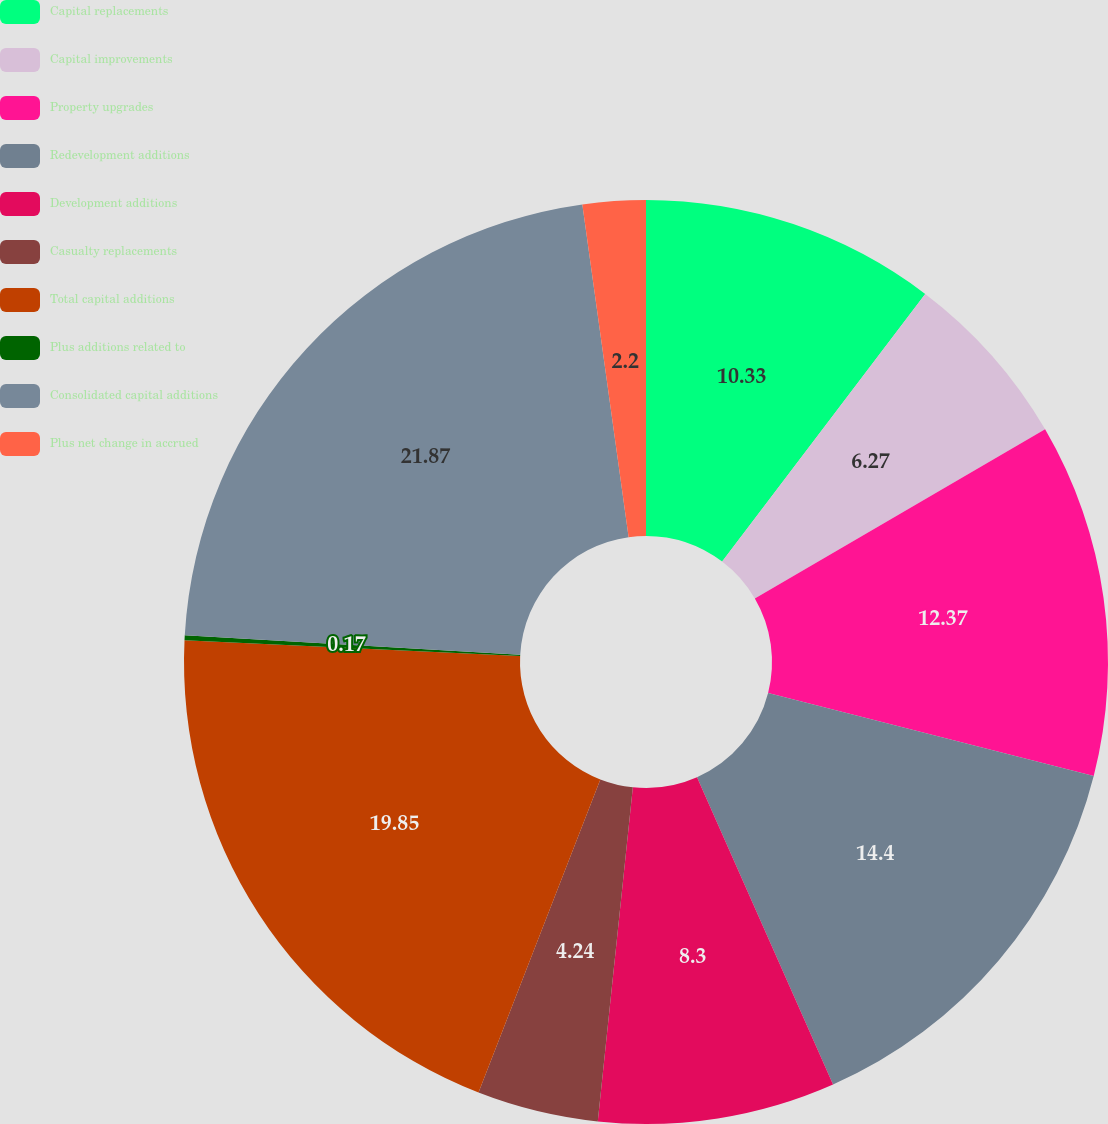<chart> <loc_0><loc_0><loc_500><loc_500><pie_chart><fcel>Capital replacements<fcel>Capital improvements<fcel>Property upgrades<fcel>Redevelopment additions<fcel>Development additions<fcel>Casualty replacements<fcel>Total capital additions<fcel>Plus additions related to<fcel>Consolidated capital additions<fcel>Plus net change in accrued<nl><fcel>10.33%<fcel>6.27%<fcel>12.37%<fcel>14.4%<fcel>8.3%<fcel>4.24%<fcel>19.85%<fcel>0.17%<fcel>21.88%<fcel>2.2%<nl></chart> 